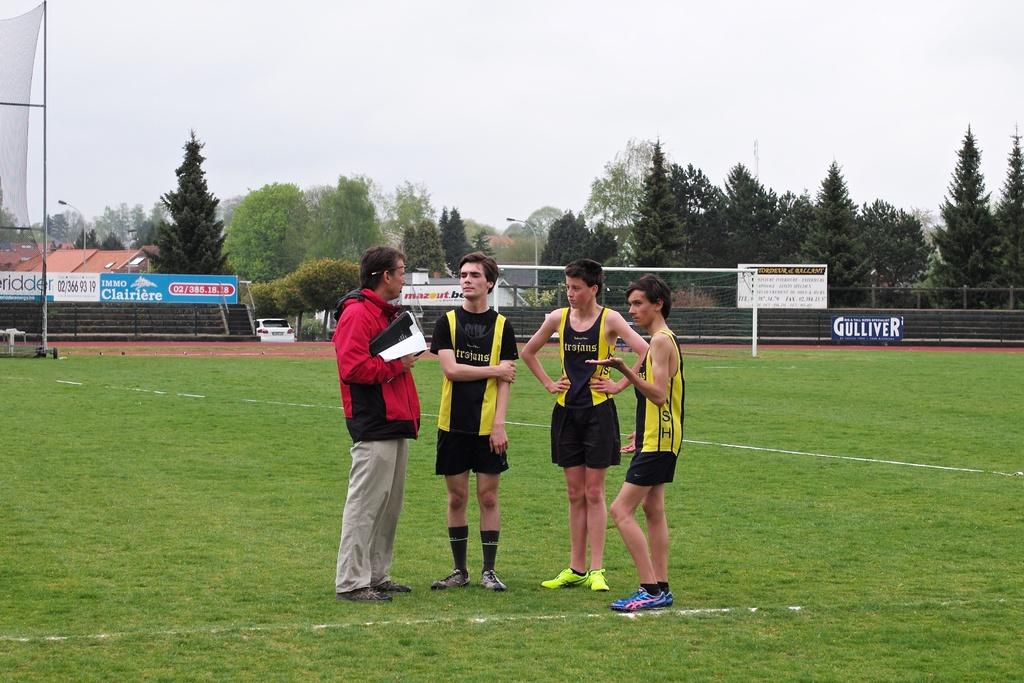Provide a one-sentence caption for the provided image. Gulliver has a big blue banner along the fence. 